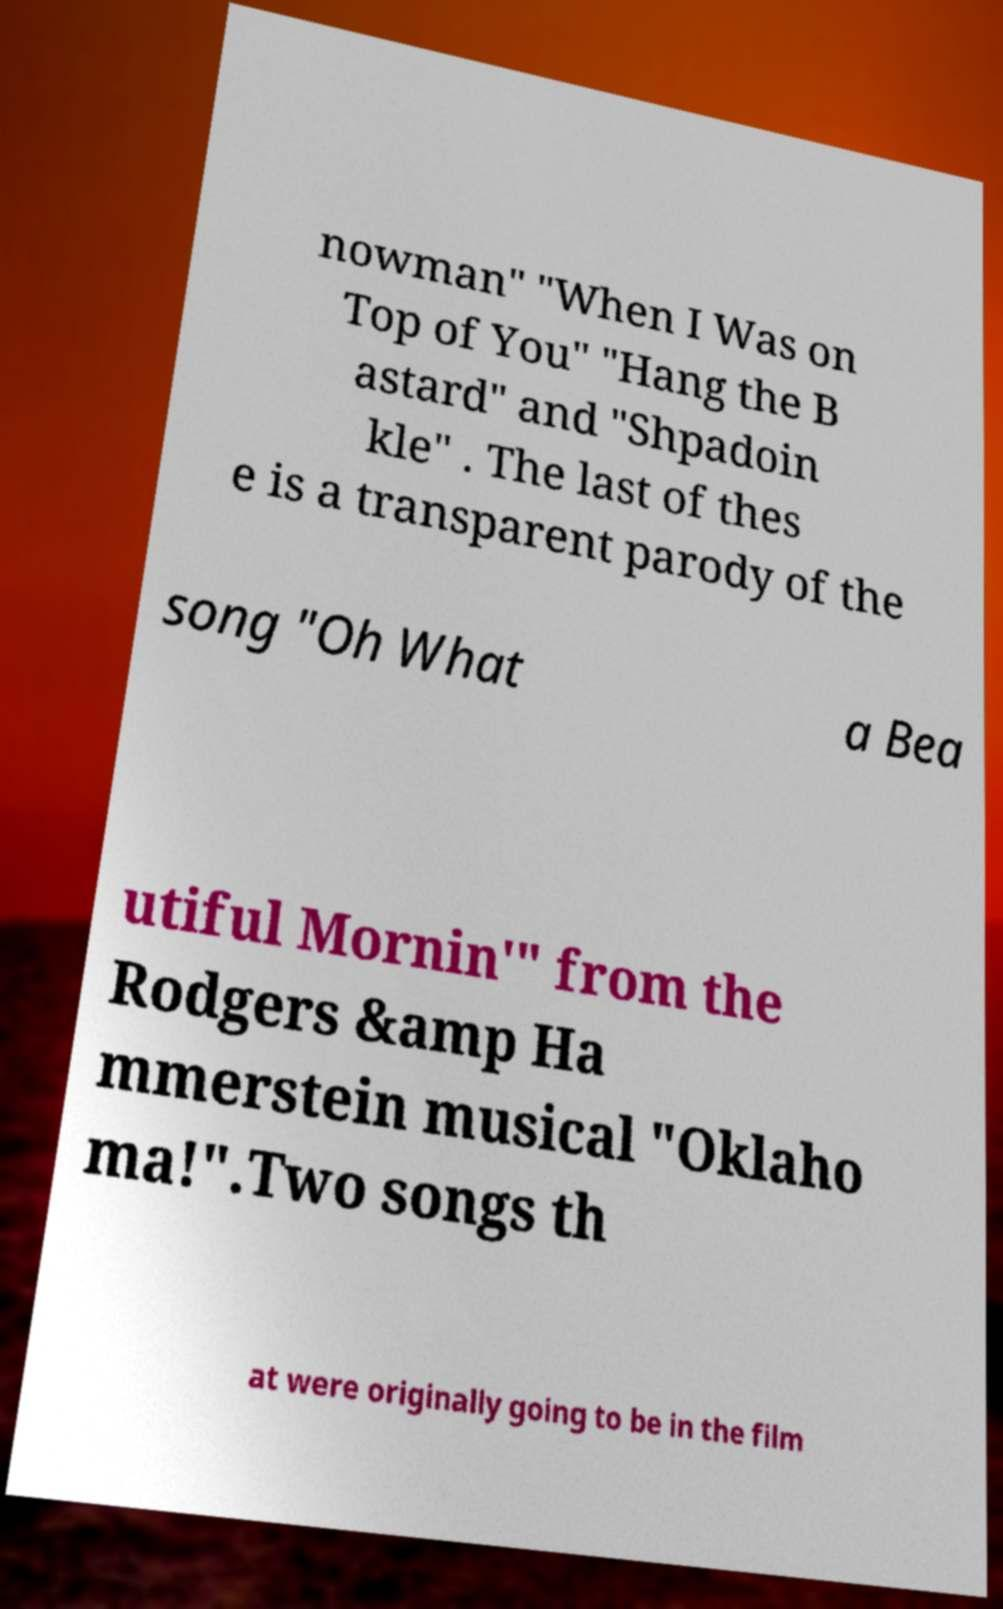For documentation purposes, I need the text within this image transcribed. Could you provide that? nowman" "When I Was on Top of You" "Hang the B astard" and "Shpadoin kle" . The last of thes e is a transparent parody of the song "Oh What a Bea utiful Mornin'" from the Rodgers &amp Ha mmerstein musical "Oklaho ma!".Two songs th at were originally going to be in the film 